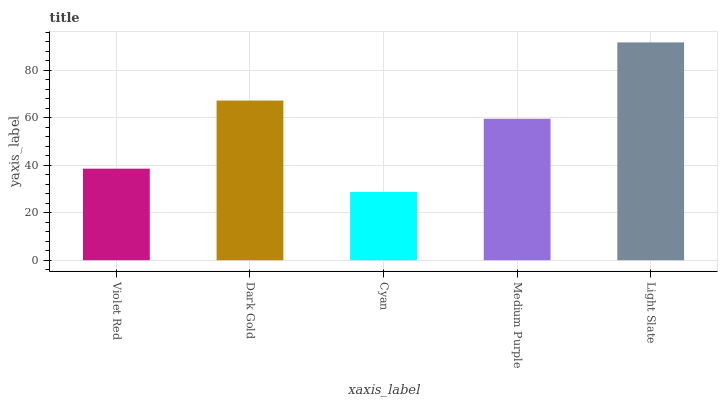Is Cyan the minimum?
Answer yes or no. Yes. Is Light Slate the maximum?
Answer yes or no. Yes. Is Dark Gold the minimum?
Answer yes or no. No. Is Dark Gold the maximum?
Answer yes or no. No. Is Dark Gold greater than Violet Red?
Answer yes or no. Yes. Is Violet Red less than Dark Gold?
Answer yes or no. Yes. Is Violet Red greater than Dark Gold?
Answer yes or no. No. Is Dark Gold less than Violet Red?
Answer yes or no. No. Is Medium Purple the high median?
Answer yes or no. Yes. Is Medium Purple the low median?
Answer yes or no. Yes. Is Light Slate the high median?
Answer yes or no. No. Is Light Slate the low median?
Answer yes or no. No. 